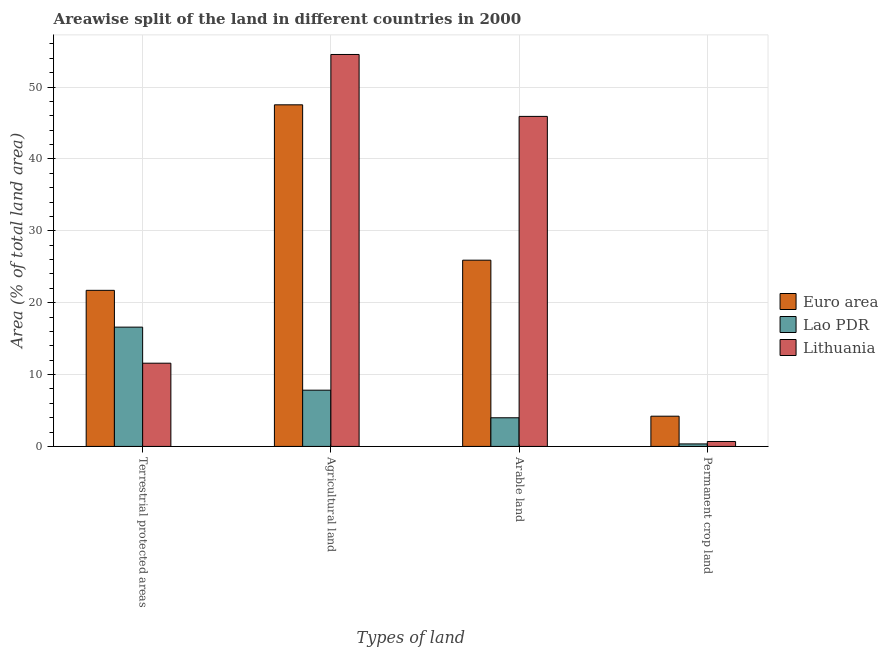How many groups of bars are there?
Offer a terse response. 4. Are the number of bars per tick equal to the number of legend labels?
Offer a terse response. Yes. How many bars are there on the 1st tick from the left?
Make the answer very short. 3. What is the label of the 4th group of bars from the left?
Offer a very short reply. Permanent crop land. What is the percentage of land under terrestrial protection in Euro area?
Your answer should be compact. 21.72. Across all countries, what is the maximum percentage of area under arable land?
Provide a short and direct response. 45.92. Across all countries, what is the minimum percentage of area under permanent crop land?
Provide a succinct answer. 0.35. In which country was the percentage of area under agricultural land maximum?
Give a very brief answer. Lithuania. In which country was the percentage of land under terrestrial protection minimum?
Ensure brevity in your answer.  Lithuania. What is the total percentage of area under agricultural land in the graph?
Keep it short and to the point. 109.88. What is the difference between the percentage of area under agricultural land in Lao PDR and that in Euro area?
Your response must be concise. -39.7. What is the difference between the percentage of area under permanent crop land in Lao PDR and the percentage of area under arable land in Lithuania?
Ensure brevity in your answer.  -45.56. What is the average percentage of land under terrestrial protection per country?
Provide a short and direct response. 16.63. What is the difference between the percentage of area under agricultural land and percentage of area under arable land in Lithuania?
Your answer should be very brief. 8.62. What is the ratio of the percentage of land under terrestrial protection in Euro area to that in Lao PDR?
Your answer should be compact. 1.31. What is the difference between the highest and the second highest percentage of area under agricultural land?
Offer a very short reply. 7. What is the difference between the highest and the lowest percentage of land under terrestrial protection?
Offer a very short reply. 10.14. In how many countries, is the percentage of area under arable land greater than the average percentage of area under arable land taken over all countries?
Ensure brevity in your answer.  2. What does the 3rd bar from the right in Permanent crop land represents?
Your response must be concise. Euro area. Is it the case that in every country, the sum of the percentage of land under terrestrial protection and percentage of area under agricultural land is greater than the percentage of area under arable land?
Provide a succinct answer. Yes. Are all the bars in the graph horizontal?
Keep it short and to the point. No. How many countries are there in the graph?
Your answer should be very brief. 3. What is the difference between two consecutive major ticks on the Y-axis?
Make the answer very short. 10. Are the values on the major ticks of Y-axis written in scientific E-notation?
Offer a very short reply. No. How many legend labels are there?
Offer a terse response. 3. How are the legend labels stacked?
Make the answer very short. Vertical. What is the title of the graph?
Your answer should be compact. Areawise split of the land in different countries in 2000. Does "Congo (Republic)" appear as one of the legend labels in the graph?
Your response must be concise. No. What is the label or title of the X-axis?
Your response must be concise. Types of land. What is the label or title of the Y-axis?
Provide a short and direct response. Area (% of total land area). What is the Area (% of total land area) in Euro area in Terrestrial protected areas?
Your answer should be compact. 21.72. What is the Area (% of total land area) in Lao PDR in Terrestrial protected areas?
Offer a terse response. 16.6. What is the Area (% of total land area) in Lithuania in Terrestrial protected areas?
Your answer should be compact. 11.58. What is the Area (% of total land area) in Euro area in Agricultural land?
Your answer should be compact. 47.53. What is the Area (% of total land area) of Lao PDR in Agricultural land?
Offer a very short reply. 7.82. What is the Area (% of total land area) in Lithuania in Agricultural land?
Offer a terse response. 54.53. What is the Area (% of total land area) of Euro area in Arable land?
Keep it short and to the point. 25.91. What is the Area (% of total land area) in Lao PDR in Arable land?
Your response must be concise. 3.99. What is the Area (% of total land area) in Lithuania in Arable land?
Ensure brevity in your answer.  45.92. What is the Area (% of total land area) in Euro area in Permanent crop land?
Offer a terse response. 4.21. What is the Area (% of total land area) in Lao PDR in Permanent crop land?
Offer a terse response. 0.35. What is the Area (% of total land area) in Lithuania in Permanent crop land?
Your answer should be compact. 0.69. Across all Types of land, what is the maximum Area (% of total land area) in Euro area?
Your answer should be compact. 47.53. Across all Types of land, what is the maximum Area (% of total land area) of Lao PDR?
Offer a terse response. 16.6. Across all Types of land, what is the maximum Area (% of total land area) in Lithuania?
Your answer should be compact. 54.53. Across all Types of land, what is the minimum Area (% of total land area) in Euro area?
Offer a terse response. 4.21. Across all Types of land, what is the minimum Area (% of total land area) in Lao PDR?
Your response must be concise. 0.35. Across all Types of land, what is the minimum Area (% of total land area) in Lithuania?
Your answer should be very brief. 0.69. What is the total Area (% of total land area) in Euro area in the graph?
Provide a short and direct response. 99.36. What is the total Area (% of total land area) in Lao PDR in the graph?
Your response must be concise. 28.76. What is the total Area (% of total land area) in Lithuania in the graph?
Your response must be concise. 112.71. What is the difference between the Area (% of total land area) in Euro area in Terrestrial protected areas and that in Agricultural land?
Keep it short and to the point. -25.81. What is the difference between the Area (% of total land area) of Lao PDR in Terrestrial protected areas and that in Agricultural land?
Your answer should be compact. 8.77. What is the difference between the Area (% of total land area) of Lithuania in Terrestrial protected areas and that in Agricultural land?
Your response must be concise. -42.95. What is the difference between the Area (% of total land area) of Euro area in Terrestrial protected areas and that in Arable land?
Offer a terse response. -4.2. What is the difference between the Area (% of total land area) in Lao PDR in Terrestrial protected areas and that in Arable land?
Make the answer very short. 12.61. What is the difference between the Area (% of total land area) of Lithuania in Terrestrial protected areas and that in Arable land?
Keep it short and to the point. -34.34. What is the difference between the Area (% of total land area) of Euro area in Terrestrial protected areas and that in Permanent crop land?
Offer a very short reply. 17.51. What is the difference between the Area (% of total land area) in Lao PDR in Terrestrial protected areas and that in Permanent crop land?
Provide a short and direct response. 16.25. What is the difference between the Area (% of total land area) in Lithuania in Terrestrial protected areas and that in Permanent crop land?
Offer a terse response. 10.89. What is the difference between the Area (% of total land area) of Euro area in Agricultural land and that in Arable land?
Provide a succinct answer. 21.61. What is the difference between the Area (% of total land area) of Lao PDR in Agricultural land and that in Arable land?
Give a very brief answer. 3.84. What is the difference between the Area (% of total land area) in Lithuania in Agricultural land and that in Arable land?
Keep it short and to the point. 8.62. What is the difference between the Area (% of total land area) of Euro area in Agricultural land and that in Permanent crop land?
Your answer should be compact. 43.32. What is the difference between the Area (% of total land area) of Lao PDR in Agricultural land and that in Permanent crop land?
Give a very brief answer. 7.47. What is the difference between the Area (% of total land area) in Lithuania in Agricultural land and that in Permanent crop land?
Make the answer very short. 53.84. What is the difference between the Area (% of total land area) in Euro area in Arable land and that in Permanent crop land?
Your response must be concise. 21.71. What is the difference between the Area (% of total land area) in Lao PDR in Arable land and that in Permanent crop land?
Your answer should be compact. 3.64. What is the difference between the Area (% of total land area) of Lithuania in Arable land and that in Permanent crop land?
Your response must be concise. 45.23. What is the difference between the Area (% of total land area) in Euro area in Terrestrial protected areas and the Area (% of total land area) in Lao PDR in Agricultural land?
Make the answer very short. 13.89. What is the difference between the Area (% of total land area) of Euro area in Terrestrial protected areas and the Area (% of total land area) of Lithuania in Agricultural land?
Give a very brief answer. -32.81. What is the difference between the Area (% of total land area) in Lao PDR in Terrestrial protected areas and the Area (% of total land area) in Lithuania in Agricultural land?
Offer a terse response. -37.93. What is the difference between the Area (% of total land area) of Euro area in Terrestrial protected areas and the Area (% of total land area) of Lao PDR in Arable land?
Give a very brief answer. 17.73. What is the difference between the Area (% of total land area) in Euro area in Terrestrial protected areas and the Area (% of total land area) in Lithuania in Arable land?
Ensure brevity in your answer.  -24.2. What is the difference between the Area (% of total land area) in Lao PDR in Terrestrial protected areas and the Area (% of total land area) in Lithuania in Arable land?
Your response must be concise. -29.32. What is the difference between the Area (% of total land area) of Euro area in Terrestrial protected areas and the Area (% of total land area) of Lao PDR in Permanent crop land?
Your answer should be compact. 21.37. What is the difference between the Area (% of total land area) of Euro area in Terrestrial protected areas and the Area (% of total land area) of Lithuania in Permanent crop land?
Give a very brief answer. 21.03. What is the difference between the Area (% of total land area) in Lao PDR in Terrestrial protected areas and the Area (% of total land area) in Lithuania in Permanent crop land?
Your response must be concise. 15.91. What is the difference between the Area (% of total land area) in Euro area in Agricultural land and the Area (% of total land area) in Lao PDR in Arable land?
Your response must be concise. 43.54. What is the difference between the Area (% of total land area) in Euro area in Agricultural land and the Area (% of total land area) in Lithuania in Arable land?
Give a very brief answer. 1.61. What is the difference between the Area (% of total land area) in Lao PDR in Agricultural land and the Area (% of total land area) in Lithuania in Arable land?
Make the answer very short. -38.09. What is the difference between the Area (% of total land area) in Euro area in Agricultural land and the Area (% of total land area) in Lao PDR in Permanent crop land?
Provide a succinct answer. 47.18. What is the difference between the Area (% of total land area) in Euro area in Agricultural land and the Area (% of total land area) in Lithuania in Permanent crop land?
Offer a very short reply. 46.84. What is the difference between the Area (% of total land area) of Lao PDR in Agricultural land and the Area (% of total land area) of Lithuania in Permanent crop land?
Give a very brief answer. 7.14. What is the difference between the Area (% of total land area) in Euro area in Arable land and the Area (% of total land area) in Lao PDR in Permanent crop land?
Your response must be concise. 25.56. What is the difference between the Area (% of total land area) of Euro area in Arable land and the Area (% of total land area) of Lithuania in Permanent crop land?
Make the answer very short. 25.23. What is the difference between the Area (% of total land area) of Lao PDR in Arable land and the Area (% of total land area) of Lithuania in Permanent crop land?
Provide a short and direct response. 3.3. What is the average Area (% of total land area) of Euro area per Types of land?
Give a very brief answer. 24.84. What is the average Area (% of total land area) of Lao PDR per Types of land?
Make the answer very short. 7.19. What is the average Area (% of total land area) of Lithuania per Types of land?
Offer a very short reply. 28.18. What is the difference between the Area (% of total land area) of Euro area and Area (% of total land area) of Lao PDR in Terrestrial protected areas?
Ensure brevity in your answer.  5.12. What is the difference between the Area (% of total land area) of Euro area and Area (% of total land area) of Lithuania in Terrestrial protected areas?
Keep it short and to the point. 10.14. What is the difference between the Area (% of total land area) in Lao PDR and Area (% of total land area) in Lithuania in Terrestrial protected areas?
Your answer should be very brief. 5.02. What is the difference between the Area (% of total land area) of Euro area and Area (% of total land area) of Lao PDR in Agricultural land?
Your answer should be compact. 39.7. What is the difference between the Area (% of total land area) in Euro area and Area (% of total land area) in Lithuania in Agricultural land?
Offer a very short reply. -7. What is the difference between the Area (% of total land area) of Lao PDR and Area (% of total land area) of Lithuania in Agricultural land?
Make the answer very short. -46.71. What is the difference between the Area (% of total land area) of Euro area and Area (% of total land area) of Lao PDR in Arable land?
Make the answer very short. 21.93. What is the difference between the Area (% of total land area) in Euro area and Area (% of total land area) in Lithuania in Arable land?
Offer a very short reply. -20. What is the difference between the Area (% of total land area) in Lao PDR and Area (% of total land area) in Lithuania in Arable land?
Make the answer very short. -41.93. What is the difference between the Area (% of total land area) in Euro area and Area (% of total land area) in Lao PDR in Permanent crop land?
Make the answer very short. 3.86. What is the difference between the Area (% of total land area) of Euro area and Area (% of total land area) of Lithuania in Permanent crop land?
Your response must be concise. 3.52. What is the difference between the Area (% of total land area) in Lao PDR and Area (% of total land area) in Lithuania in Permanent crop land?
Keep it short and to the point. -0.34. What is the ratio of the Area (% of total land area) in Euro area in Terrestrial protected areas to that in Agricultural land?
Offer a terse response. 0.46. What is the ratio of the Area (% of total land area) of Lao PDR in Terrestrial protected areas to that in Agricultural land?
Make the answer very short. 2.12. What is the ratio of the Area (% of total land area) of Lithuania in Terrestrial protected areas to that in Agricultural land?
Provide a succinct answer. 0.21. What is the ratio of the Area (% of total land area) of Euro area in Terrestrial protected areas to that in Arable land?
Provide a succinct answer. 0.84. What is the ratio of the Area (% of total land area) in Lao PDR in Terrestrial protected areas to that in Arable land?
Your answer should be very brief. 4.16. What is the ratio of the Area (% of total land area) of Lithuania in Terrestrial protected areas to that in Arable land?
Keep it short and to the point. 0.25. What is the ratio of the Area (% of total land area) in Euro area in Terrestrial protected areas to that in Permanent crop land?
Ensure brevity in your answer.  5.16. What is the ratio of the Area (% of total land area) in Lao PDR in Terrestrial protected areas to that in Permanent crop land?
Ensure brevity in your answer.  47.29. What is the ratio of the Area (% of total land area) in Lithuania in Terrestrial protected areas to that in Permanent crop land?
Provide a short and direct response. 16.88. What is the ratio of the Area (% of total land area) of Euro area in Agricultural land to that in Arable land?
Provide a succinct answer. 1.83. What is the ratio of the Area (% of total land area) in Lao PDR in Agricultural land to that in Arable land?
Your response must be concise. 1.96. What is the ratio of the Area (% of total land area) of Lithuania in Agricultural land to that in Arable land?
Offer a terse response. 1.19. What is the ratio of the Area (% of total land area) in Euro area in Agricultural land to that in Permanent crop land?
Provide a succinct answer. 11.3. What is the ratio of the Area (% of total land area) in Lao PDR in Agricultural land to that in Permanent crop land?
Give a very brief answer. 22.3. What is the ratio of the Area (% of total land area) of Lithuania in Agricultural land to that in Permanent crop land?
Make the answer very short. 79.49. What is the ratio of the Area (% of total land area) in Euro area in Arable land to that in Permanent crop land?
Offer a very short reply. 6.16. What is the ratio of the Area (% of total land area) in Lao PDR in Arable land to that in Permanent crop land?
Your answer should be very brief. 11.36. What is the ratio of the Area (% of total land area) of Lithuania in Arable land to that in Permanent crop land?
Provide a short and direct response. 66.93. What is the difference between the highest and the second highest Area (% of total land area) of Euro area?
Give a very brief answer. 21.61. What is the difference between the highest and the second highest Area (% of total land area) in Lao PDR?
Your answer should be very brief. 8.77. What is the difference between the highest and the second highest Area (% of total land area) in Lithuania?
Keep it short and to the point. 8.62. What is the difference between the highest and the lowest Area (% of total land area) of Euro area?
Your answer should be very brief. 43.32. What is the difference between the highest and the lowest Area (% of total land area) in Lao PDR?
Offer a very short reply. 16.25. What is the difference between the highest and the lowest Area (% of total land area) in Lithuania?
Provide a short and direct response. 53.84. 